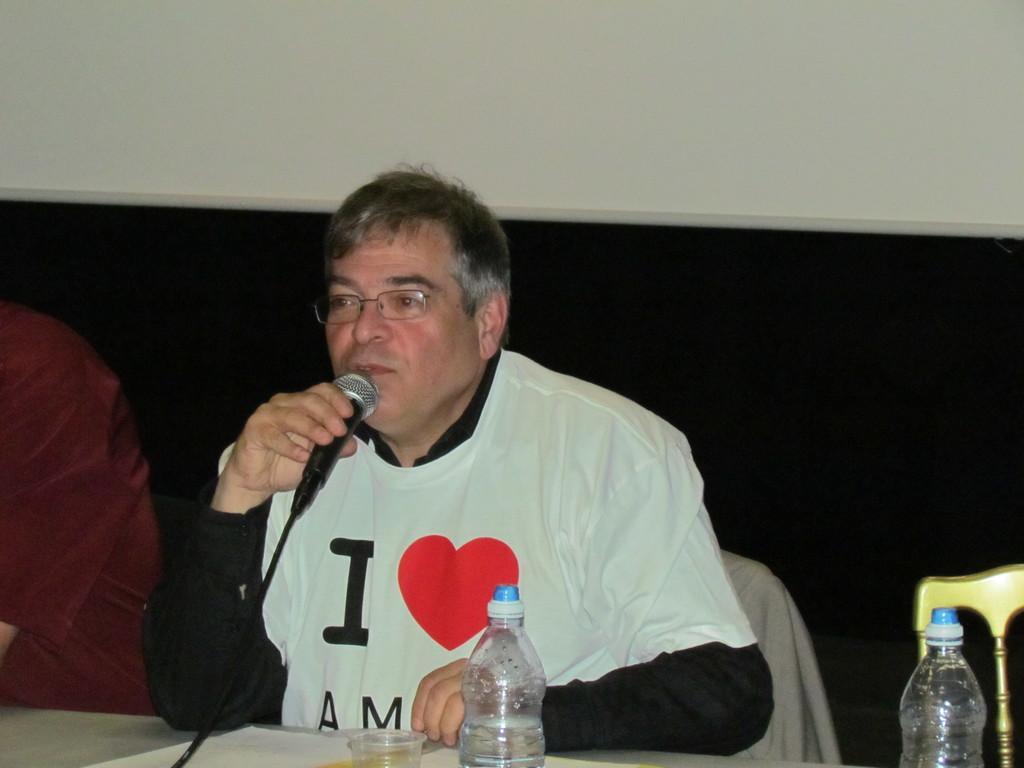In one or two sentences, can you explain what this image depicts? There is a man sitting in a chair and speaking in a micro phone in front of the table where bottles and glass are placed. 